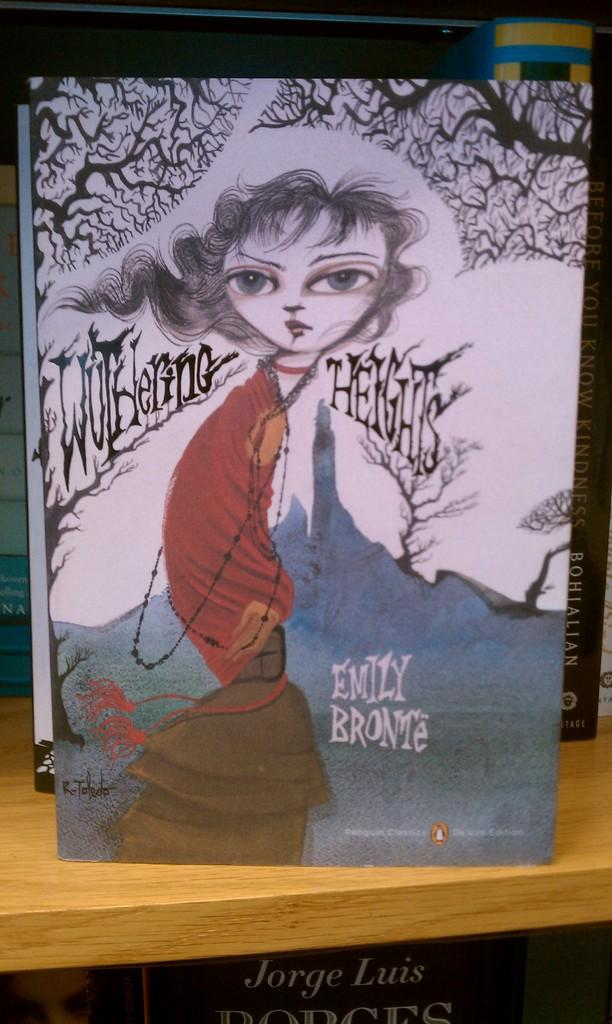<image>
Give a short and clear explanation of the subsequent image. The book shown is writte by the author Emily Bronte. 